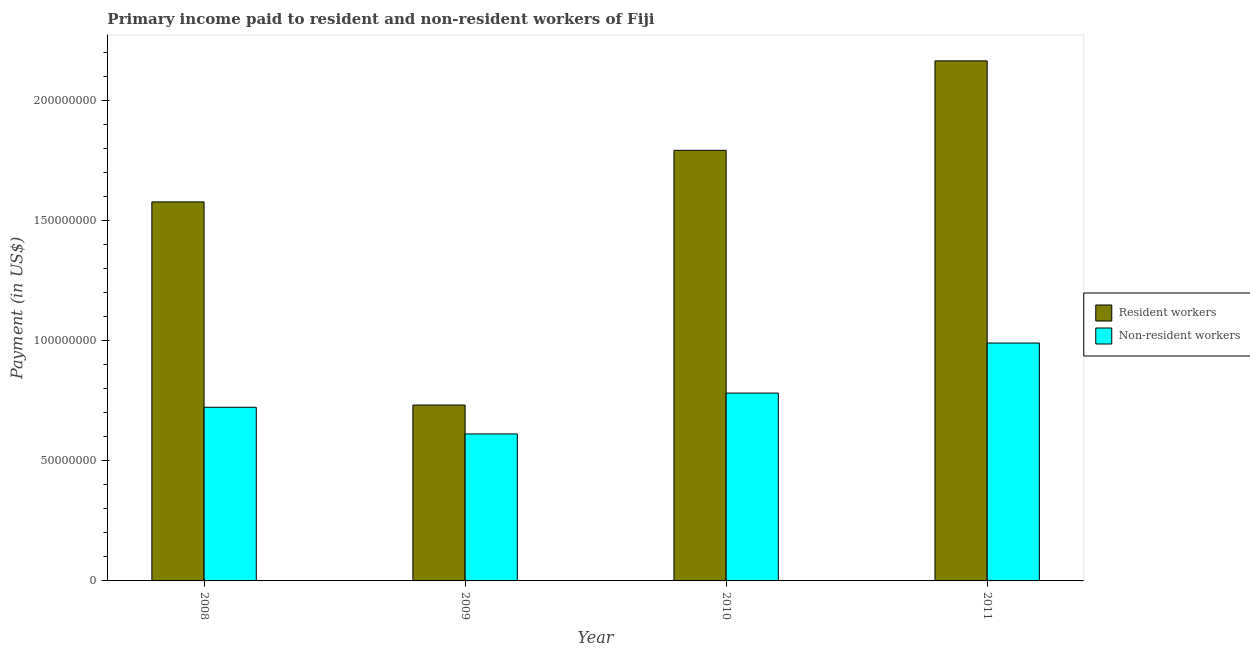How many different coloured bars are there?
Your response must be concise. 2. How many groups of bars are there?
Provide a short and direct response. 4. How many bars are there on the 2nd tick from the right?
Your answer should be compact. 2. What is the label of the 4th group of bars from the left?
Ensure brevity in your answer.  2011. What is the payment made to non-resident workers in 2011?
Ensure brevity in your answer.  9.91e+07. Across all years, what is the maximum payment made to resident workers?
Offer a very short reply. 2.17e+08. Across all years, what is the minimum payment made to non-resident workers?
Make the answer very short. 6.12e+07. In which year was the payment made to resident workers maximum?
Keep it short and to the point. 2011. What is the total payment made to non-resident workers in the graph?
Provide a succinct answer. 3.11e+08. What is the difference between the payment made to non-resident workers in 2009 and that in 2010?
Keep it short and to the point. -1.70e+07. What is the difference between the payment made to non-resident workers in 2011 and the payment made to resident workers in 2008?
Offer a terse response. 2.68e+07. What is the average payment made to resident workers per year?
Your answer should be compact. 1.57e+08. In the year 2009, what is the difference between the payment made to resident workers and payment made to non-resident workers?
Your answer should be compact. 0. In how many years, is the payment made to non-resident workers greater than 140000000 US$?
Make the answer very short. 0. What is the ratio of the payment made to non-resident workers in 2008 to that in 2009?
Ensure brevity in your answer.  1.18. Is the difference between the payment made to resident workers in 2010 and 2011 greater than the difference between the payment made to non-resident workers in 2010 and 2011?
Offer a terse response. No. What is the difference between the highest and the second highest payment made to resident workers?
Provide a short and direct response. 3.72e+07. What is the difference between the highest and the lowest payment made to non-resident workers?
Provide a succinct answer. 3.79e+07. What does the 1st bar from the left in 2009 represents?
Your answer should be compact. Resident workers. What does the 2nd bar from the right in 2010 represents?
Offer a very short reply. Resident workers. How many bars are there?
Give a very brief answer. 8. Are all the bars in the graph horizontal?
Your answer should be compact. No. What is the difference between two consecutive major ticks on the Y-axis?
Your answer should be compact. 5.00e+07. How are the legend labels stacked?
Your answer should be very brief. Vertical. What is the title of the graph?
Provide a short and direct response. Primary income paid to resident and non-resident workers of Fiji. What is the label or title of the X-axis?
Ensure brevity in your answer.  Year. What is the label or title of the Y-axis?
Provide a short and direct response. Payment (in US$). What is the Payment (in US$) of Resident workers in 2008?
Offer a very short reply. 1.58e+08. What is the Payment (in US$) in Non-resident workers in 2008?
Your response must be concise. 7.23e+07. What is the Payment (in US$) in Resident workers in 2009?
Keep it short and to the point. 7.33e+07. What is the Payment (in US$) of Non-resident workers in 2009?
Provide a short and direct response. 6.12e+07. What is the Payment (in US$) in Resident workers in 2010?
Offer a very short reply. 1.79e+08. What is the Payment (in US$) of Non-resident workers in 2010?
Your answer should be very brief. 7.82e+07. What is the Payment (in US$) in Resident workers in 2011?
Your response must be concise. 2.17e+08. What is the Payment (in US$) of Non-resident workers in 2011?
Keep it short and to the point. 9.91e+07. Across all years, what is the maximum Payment (in US$) of Resident workers?
Offer a very short reply. 2.17e+08. Across all years, what is the maximum Payment (in US$) of Non-resident workers?
Offer a very short reply. 9.91e+07. Across all years, what is the minimum Payment (in US$) of Resident workers?
Give a very brief answer. 7.33e+07. Across all years, what is the minimum Payment (in US$) in Non-resident workers?
Your answer should be compact. 6.12e+07. What is the total Payment (in US$) of Resident workers in the graph?
Keep it short and to the point. 6.27e+08. What is the total Payment (in US$) in Non-resident workers in the graph?
Give a very brief answer. 3.11e+08. What is the difference between the Payment (in US$) of Resident workers in 2008 and that in 2009?
Offer a very short reply. 8.46e+07. What is the difference between the Payment (in US$) in Non-resident workers in 2008 and that in 2009?
Ensure brevity in your answer.  1.11e+07. What is the difference between the Payment (in US$) in Resident workers in 2008 and that in 2010?
Your answer should be very brief. -2.15e+07. What is the difference between the Payment (in US$) of Non-resident workers in 2008 and that in 2010?
Your answer should be very brief. -5.91e+06. What is the difference between the Payment (in US$) in Resident workers in 2008 and that in 2011?
Give a very brief answer. -5.87e+07. What is the difference between the Payment (in US$) of Non-resident workers in 2008 and that in 2011?
Provide a short and direct response. -2.68e+07. What is the difference between the Payment (in US$) in Resident workers in 2009 and that in 2010?
Give a very brief answer. -1.06e+08. What is the difference between the Payment (in US$) in Non-resident workers in 2009 and that in 2010?
Your answer should be very brief. -1.70e+07. What is the difference between the Payment (in US$) in Resident workers in 2009 and that in 2011?
Your response must be concise. -1.43e+08. What is the difference between the Payment (in US$) of Non-resident workers in 2009 and that in 2011?
Your answer should be compact. -3.79e+07. What is the difference between the Payment (in US$) of Resident workers in 2010 and that in 2011?
Keep it short and to the point. -3.72e+07. What is the difference between the Payment (in US$) in Non-resident workers in 2010 and that in 2011?
Your response must be concise. -2.08e+07. What is the difference between the Payment (in US$) of Resident workers in 2008 and the Payment (in US$) of Non-resident workers in 2009?
Offer a terse response. 9.66e+07. What is the difference between the Payment (in US$) of Resident workers in 2008 and the Payment (in US$) of Non-resident workers in 2010?
Make the answer very short. 7.96e+07. What is the difference between the Payment (in US$) of Resident workers in 2008 and the Payment (in US$) of Non-resident workers in 2011?
Your answer should be compact. 5.88e+07. What is the difference between the Payment (in US$) in Resident workers in 2009 and the Payment (in US$) in Non-resident workers in 2010?
Your response must be concise. -4.99e+06. What is the difference between the Payment (in US$) of Resident workers in 2009 and the Payment (in US$) of Non-resident workers in 2011?
Make the answer very short. -2.58e+07. What is the difference between the Payment (in US$) in Resident workers in 2010 and the Payment (in US$) in Non-resident workers in 2011?
Make the answer very short. 8.03e+07. What is the average Payment (in US$) in Resident workers per year?
Your answer should be very brief. 1.57e+08. What is the average Payment (in US$) in Non-resident workers per year?
Provide a succinct answer. 7.77e+07. In the year 2008, what is the difference between the Payment (in US$) in Resident workers and Payment (in US$) in Non-resident workers?
Ensure brevity in your answer.  8.55e+07. In the year 2009, what is the difference between the Payment (in US$) of Resident workers and Payment (in US$) of Non-resident workers?
Your response must be concise. 1.20e+07. In the year 2010, what is the difference between the Payment (in US$) in Resident workers and Payment (in US$) in Non-resident workers?
Ensure brevity in your answer.  1.01e+08. In the year 2011, what is the difference between the Payment (in US$) of Resident workers and Payment (in US$) of Non-resident workers?
Your answer should be very brief. 1.18e+08. What is the ratio of the Payment (in US$) of Resident workers in 2008 to that in 2009?
Give a very brief answer. 2.15. What is the ratio of the Payment (in US$) in Non-resident workers in 2008 to that in 2009?
Your response must be concise. 1.18. What is the ratio of the Payment (in US$) in Resident workers in 2008 to that in 2010?
Give a very brief answer. 0.88. What is the ratio of the Payment (in US$) in Non-resident workers in 2008 to that in 2010?
Ensure brevity in your answer.  0.92. What is the ratio of the Payment (in US$) of Resident workers in 2008 to that in 2011?
Make the answer very short. 0.73. What is the ratio of the Payment (in US$) of Non-resident workers in 2008 to that in 2011?
Provide a short and direct response. 0.73. What is the ratio of the Payment (in US$) in Resident workers in 2009 to that in 2010?
Ensure brevity in your answer.  0.41. What is the ratio of the Payment (in US$) of Non-resident workers in 2009 to that in 2010?
Ensure brevity in your answer.  0.78. What is the ratio of the Payment (in US$) of Resident workers in 2009 to that in 2011?
Ensure brevity in your answer.  0.34. What is the ratio of the Payment (in US$) of Non-resident workers in 2009 to that in 2011?
Your answer should be very brief. 0.62. What is the ratio of the Payment (in US$) in Resident workers in 2010 to that in 2011?
Provide a short and direct response. 0.83. What is the ratio of the Payment (in US$) in Non-resident workers in 2010 to that in 2011?
Offer a terse response. 0.79. What is the difference between the highest and the second highest Payment (in US$) of Resident workers?
Your response must be concise. 3.72e+07. What is the difference between the highest and the second highest Payment (in US$) of Non-resident workers?
Provide a succinct answer. 2.08e+07. What is the difference between the highest and the lowest Payment (in US$) of Resident workers?
Offer a terse response. 1.43e+08. What is the difference between the highest and the lowest Payment (in US$) of Non-resident workers?
Ensure brevity in your answer.  3.79e+07. 